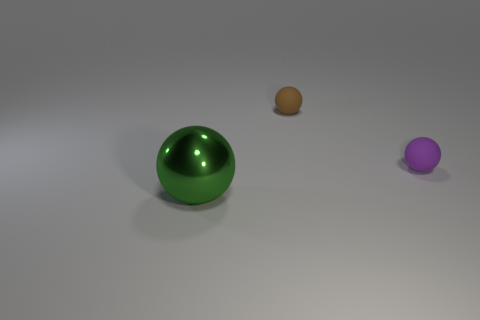Is there any other thing that is the same shape as the tiny purple rubber object?
Keep it short and to the point. Yes. Do the thing that is in front of the small purple rubber thing and the small matte object in front of the small brown matte thing have the same color?
Ensure brevity in your answer.  No. How many metal objects are big balls or purple spheres?
Offer a very short reply. 1. Is there any other thing that has the same size as the green metal object?
Your answer should be very brief. No. Is the tiny sphere that is right of the tiny brown object made of the same material as the large green thing in front of the small brown thing?
Offer a terse response. No. There is a small thing behind the purple matte thing; how many small rubber balls are in front of it?
Offer a very short reply. 1. Do the thing behind the small purple rubber sphere and the object in front of the purple rubber thing have the same shape?
Keep it short and to the point. Yes. There is a object that is right of the green ball and to the left of the purple matte object; how big is it?
Give a very brief answer. Small. The other small thing that is the same shape as the tiny brown matte thing is what color?
Keep it short and to the point. Purple. What color is the ball behind the tiny ball right of the small brown matte thing?
Keep it short and to the point. Brown. 